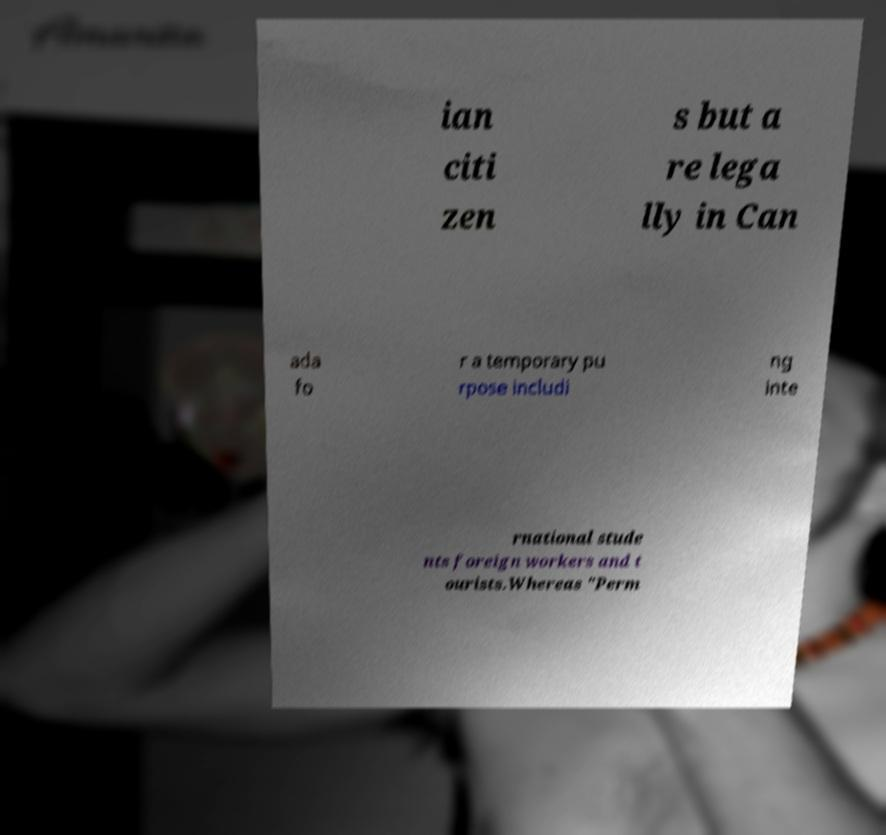Please identify and transcribe the text found in this image. ian citi zen s but a re lega lly in Can ada fo r a temporary pu rpose includi ng inte rnational stude nts foreign workers and t ourists.Whereas "Perm 